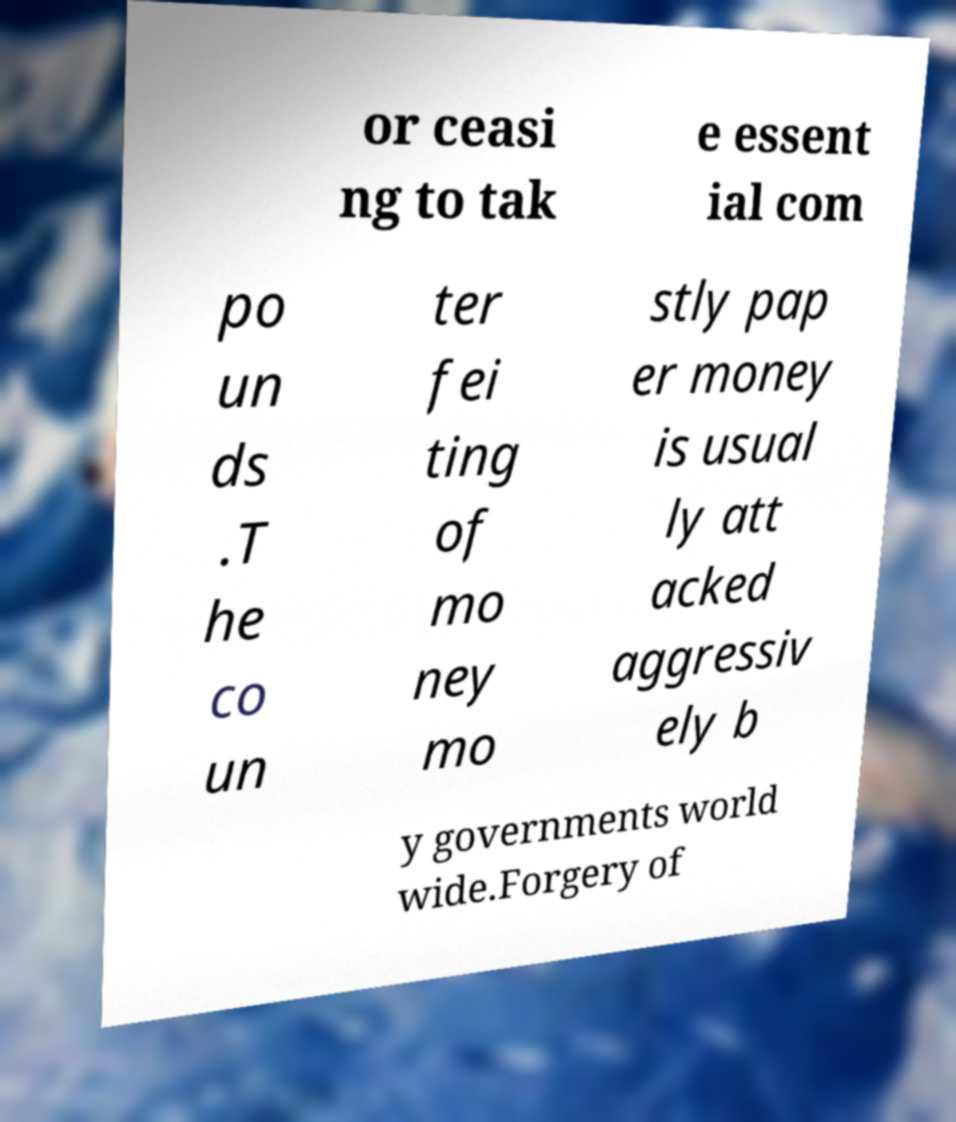Could you assist in decoding the text presented in this image and type it out clearly? or ceasi ng to tak e essent ial com po un ds .T he co un ter fei ting of mo ney mo stly pap er money is usual ly att acked aggressiv ely b y governments world wide.Forgery of 